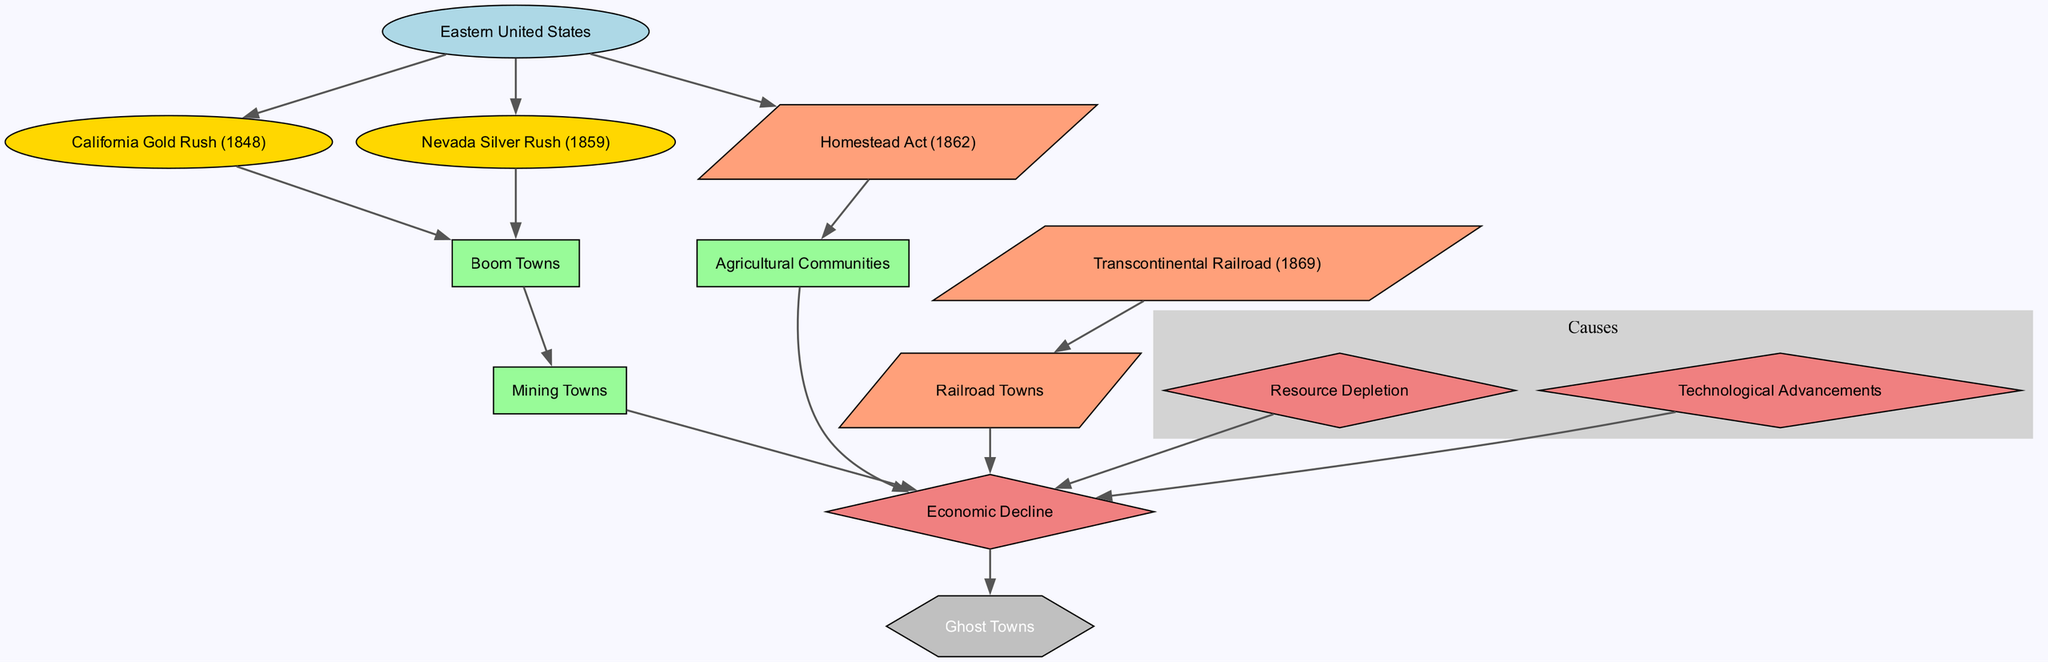What are the three main migration events leading to ghost towns? The three main migration events are the California Gold Rush (1848), the Nevada Silver Rush (1859), and the Homestead Act (1862). Each of these events is directly connected from the Eastern United States node, indicating that they were significant points of migration.
Answer: California Gold Rush (1848), Nevada Silver Rush (1859), Homestead Act (1862) Which town types evolved directly from Boom Towns? The town types that evolved directly from Boom Towns are Mining Towns. The directed edge from Boom Towns to Mining Towns indicates this relationship.
Answer: Mining Towns How many direct causes lead to Economic Decline? There are three direct causes leading to Economic Decline: Resource Depletion, Technological Advancements, and the connection from town types such as Mining Towns, Railroad Towns, and Agricultural Communities that also lead to Economic Decline. Summing these, there are four factors.
Answer: Four What is the shape of the Ghost Towns node? The Ghost Towns node is shaped like a hexagon, which is a specific shape denoted in the diagram to distinctly represent it among other types.
Answer: Hexagon Which events lead to the formation of Railroad Towns? The event that leads to the formation of Railroad Towns is the Transcontinental Railroad (1869), as there is a direct edge connecting these two nodes.
Answer: Transcontinental Railroad (1869) How do Homestead Act and Transcontinental Railroad relate to agricultural communities? The Homestead Act (1862) leads to Agricultural Communities, while the Transcontinental Railroad (1869) provides connectivity for these communities. Both events are related to the formation of agricultural areas in the West as indicated by their direct connections.
Answer: Agricultral Communities Which types of towns are connected to the Economic Decline node? The types of towns connected to the Economic Decline node are Mining Towns, Railroad Towns, and Agricultural Communities, as indicated by the respective directed edges connecting each of these town types to Economic Decline.
Answer: Mining Towns, Railroad Towns, Agricultural Communities What is the final outcome when towns experience Economic Decline? The final outcome when towns experience Economic Decline is the formation of Ghost Towns, evidenced by the direct edge leading from Economic Decline to Ghost Towns in the diagram.
Answer: Ghost Towns 